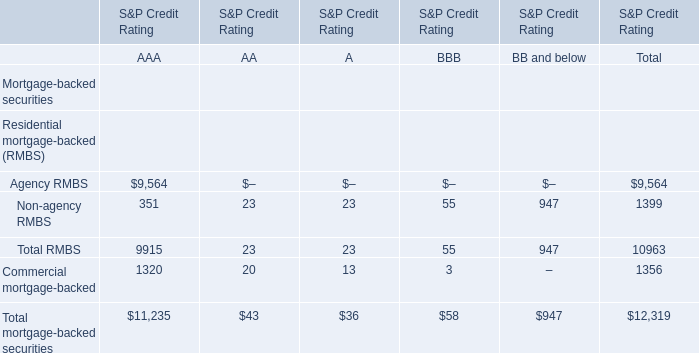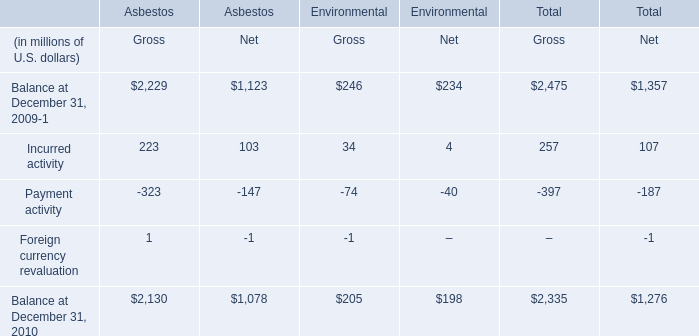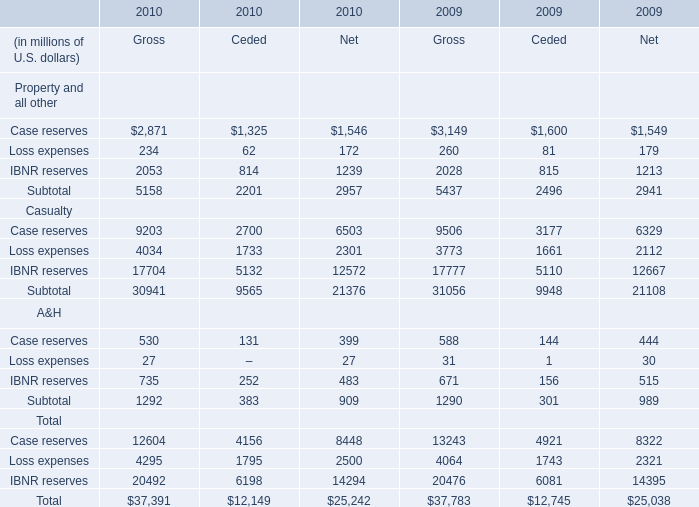What is the difference between the greatest net of reserves for property in 2009 and 2010？ (in million) 
Computations: (1546 - 1549)
Answer: -3.0. 